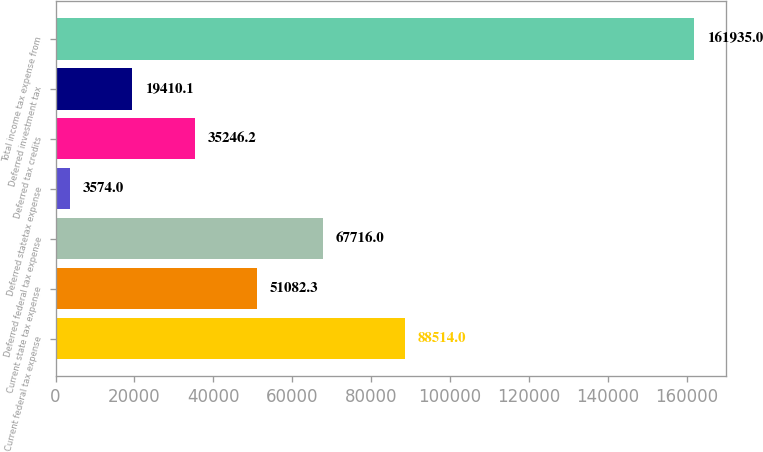<chart> <loc_0><loc_0><loc_500><loc_500><bar_chart><fcel>Current federal tax expense<fcel>Current state tax expense<fcel>Deferred federal tax expense<fcel>Deferred statetax expense<fcel>Deferred tax credits<fcel>Deferred investment tax<fcel>Total income tax expense from<nl><fcel>88514<fcel>51082.3<fcel>67716<fcel>3574<fcel>35246.2<fcel>19410.1<fcel>161935<nl></chart> 